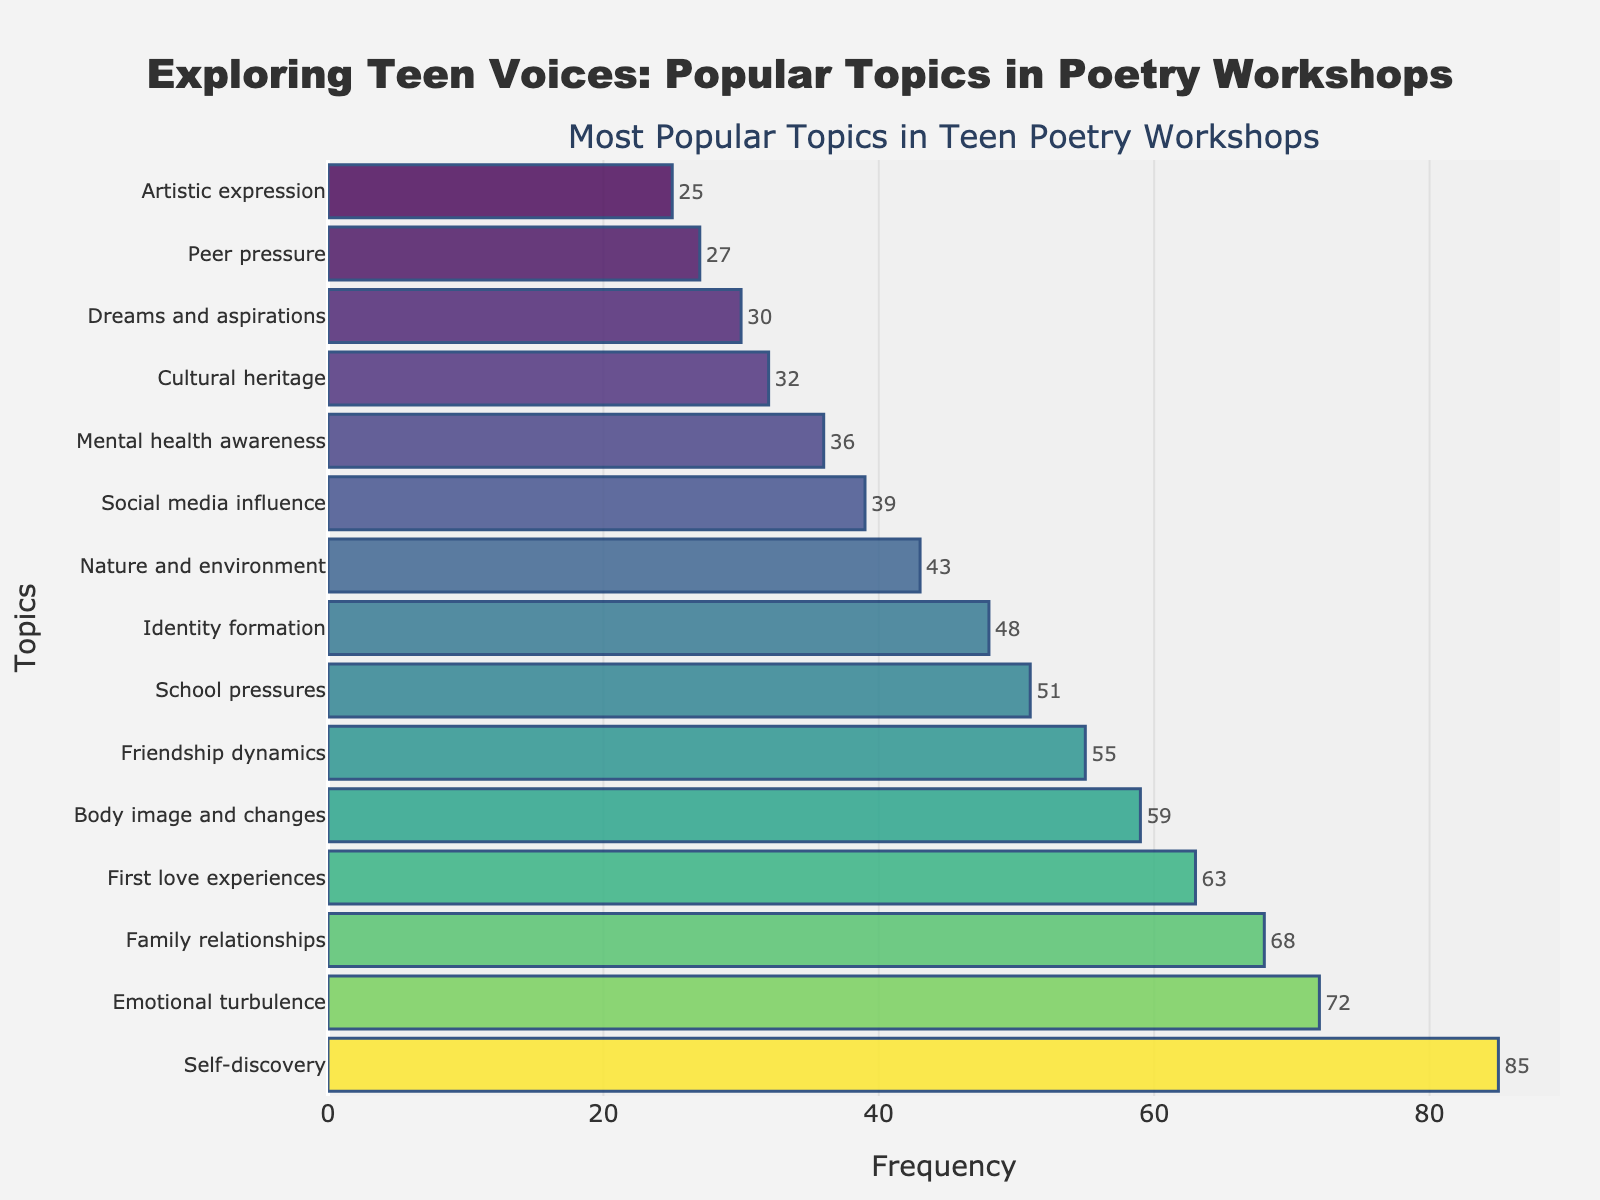Which topic is most popular in teen poetry workshops? The figure shows "Self-discovery" having the highest bar, representing the most popular topic discussed based on the frequency.
Answer: Self-discovery What is the total frequency of "Body image and changes" and "Cultural heritage"? "Body image and changes" has a frequency of 59 and "Cultural heritage" has a frequency of 32. Adding them gives 59 + 32 = 91.
Answer: 91 Which topic has a lower frequency: "Social media influence" or "Artistic expression"? Comparing the bars, "Social media influence" has a frequency of 39, whereas "Artistic expression" has a frequency of 25. Therefore, "Artistic expression" has a lower frequency.
Answer: Artistic expression What is the frequency difference between "First love experiences" and "School pressures"? "First love experiences" has a frequency of 63, and "School pressures" has a frequency of 51. The difference is 63 - 51 = 12.
Answer: 12 How many topics have a frequency of less than 50? By examining the figure, the topics with frequencies less than 50 are "Identity formation" (48), "Nature and environment" (43), "Social media influence" (39), "Mental health awareness" (36), "Cultural heritage" (32), "Dreams and aspirations" (30), "Peer pressure" (27), and "Artistic expression" (25), which totals to 8 topics.
Answer: 8 What are the frequencies of the three least discussed topics? The three shortest bars representing the least discussed topics are "Peer pressure" (27), "Artistic expression" (25), and "Dreams and aspirations" (30).
Answer: 27, 25, 30 What is the average frequency of the topics "Friendship dynamics", "School pressures", and "Mental health awareness"? Sum their frequencies: Friendship dynamics (55) + School pressures (51) + Mental health awareness (36) = 142. The average is 142 / 3 = 47.33.
Answer: 47.33 Which topics have frequencies greater than 60? The topics with frequencies greater than 60 are "Self-discovery" (85), "Emotional turbulence" (72), "Family relationships" (68), and "First love experiences" (63).
Answer: Self-discovery, Emotional turbulence, Family relationships, First love experiences 